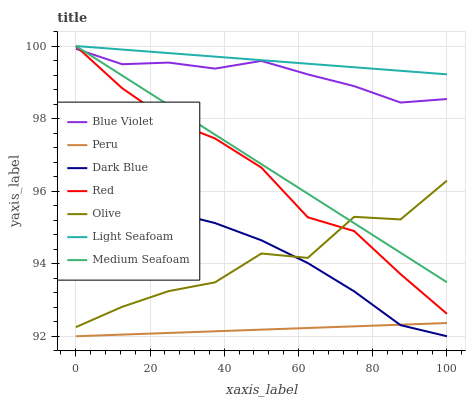Does Peru have the minimum area under the curve?
Answer yes or no. Yes. Does Light Seafoam have the maximum area under the curve?
Answer yes or no. Yes. Does Blue Violet have the minimum area under the curve?
Answer yes or no. No. Does Blue Violet have the maximum area under the curve?
Answer yes or no. No. Is Light Seafoam the smoothest?
Answer yes or no. Yes. Is Olive the roughest?
Answer yes or no. Yes. Is Blue Violet the smoothest?
Answer yes or no. No. Is Blue Violet the roughest?
Answer yes or no. No. Does Blue Violet have the lowest value?
Answer yes or no. No. Does Red have the highest value?
Answer yes or no. Yes. Does Blue Violet have the highest value?
Answer yes or no. No. Is Olive less than Blue Violet?
Answer yes or no. Yes. Is Red greater than Dark Blue?
Answer yes or no. Yes. Does Red intersect Olive?
Answer yes or no. Yes. Is Red less than Olive?
Answer yes or no. No. Is Red greater than Olive?
Answer yes or no. No. Does Olive intersect Blue Violet?
Answer yes or no. No. 